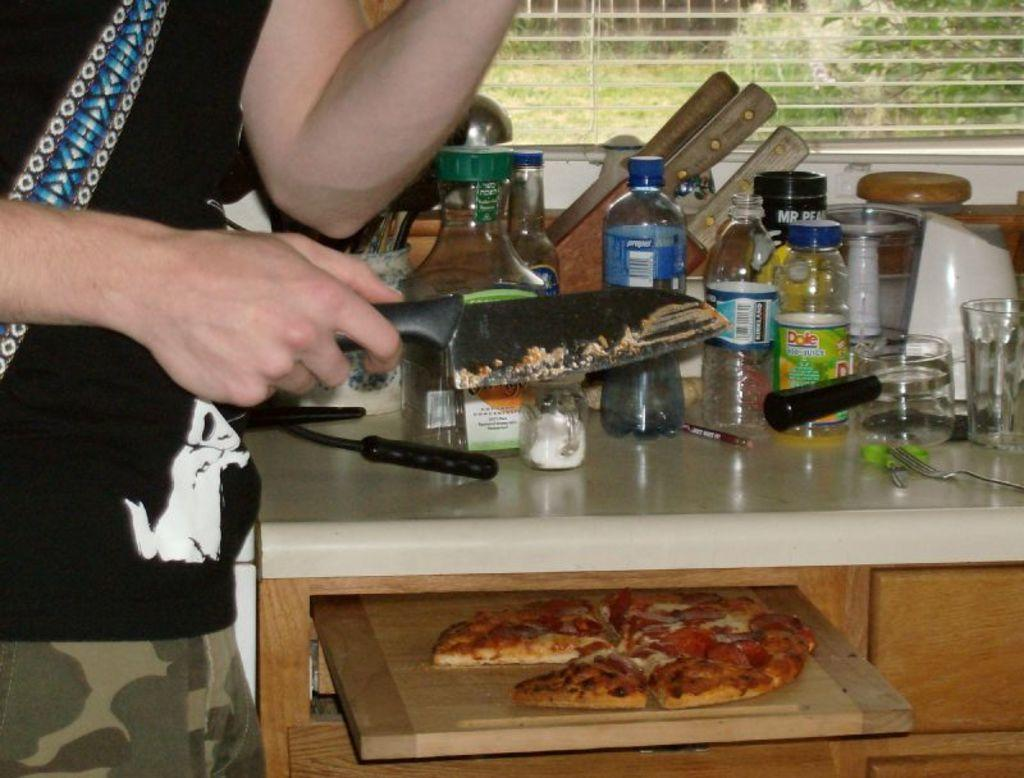<image>
Write a terse but informative summary of the picture. A person is cutting pizza and on the counter there is Kirkland water and Dole juice. 